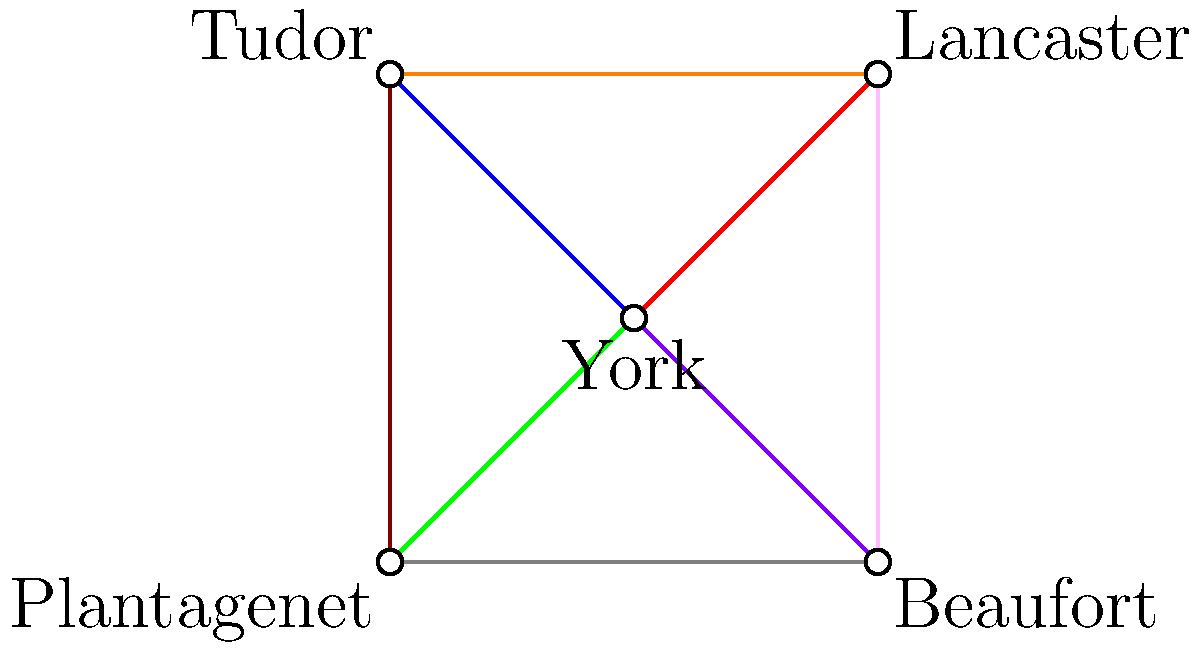In this graph depicting the alliances and conflicts between noble houses in medieval England, each edge represents a relationship between two houses. Red edges indicate strong alliances, blue edges represent uneasy truces, and all other colors signify various levels of conflict. How many houses are in direct conflict with the House of York? To solve this problem, we need to examine the edges connected to the House of York (the central vertex) and count those that represent conflicts. Let's break it down step-by-step:

1. Identify the edges connected to York:
   - York to Lancaster (red)
   - York to Tudor (blue)
   - York to Plantagenet (green)
   - York to Beaufort (purple)

2. Determine the meaning of each color:
   - Red edges indicate strong alliances
   - Blue edges represent uneasy truces
   - All other colors signify various levels of conflict

3. Count the conflict edges:
   - The red edge (York to Lancaster) is an alliance, not a conflict
   - The blue edge (York to Tudor) is an uneasy truce, not a direct conflict
   - The green edge (York to Plantagenet) represents a conflict
   - The purple edge (York to Beaufort) represents a conflict

4. Sum up the conflicts:
   There are 2 edges (green and purple) that represent direct conflicts with the House of York.

Therefore, the House of York is in direct conflict with 2 other houses.
Answer: 2 